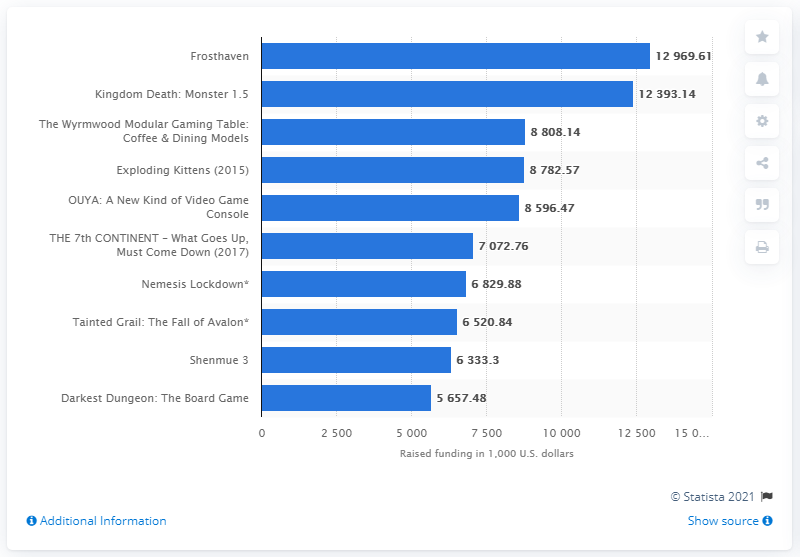Highlight a few significant elements in this photo. As of November 2020, the highest funded gaming project on Kickstarter was Frosthaven. 